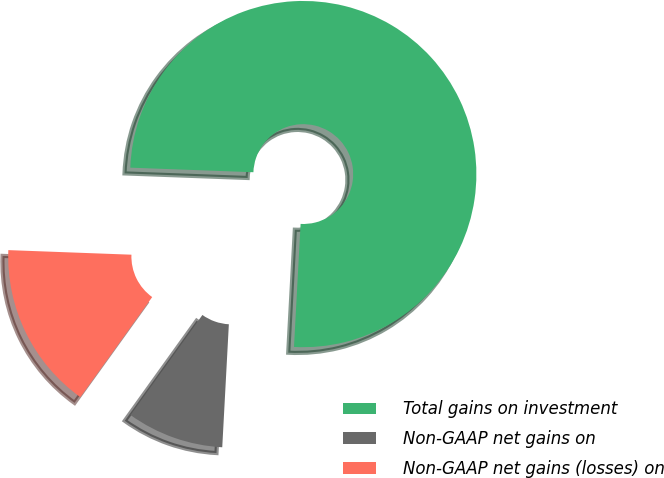Convert chart. <chart><loc_0><loc_0><loc_500><loc_500><pie_chart><fcel>Total gains on investment<fcel>Non-GAAP net gains on<fcel>Non-GAAP net gains (losses) on<nl><fcel>75.27%<fcel>9.06%<fcel>15.68%<nl></chart> 